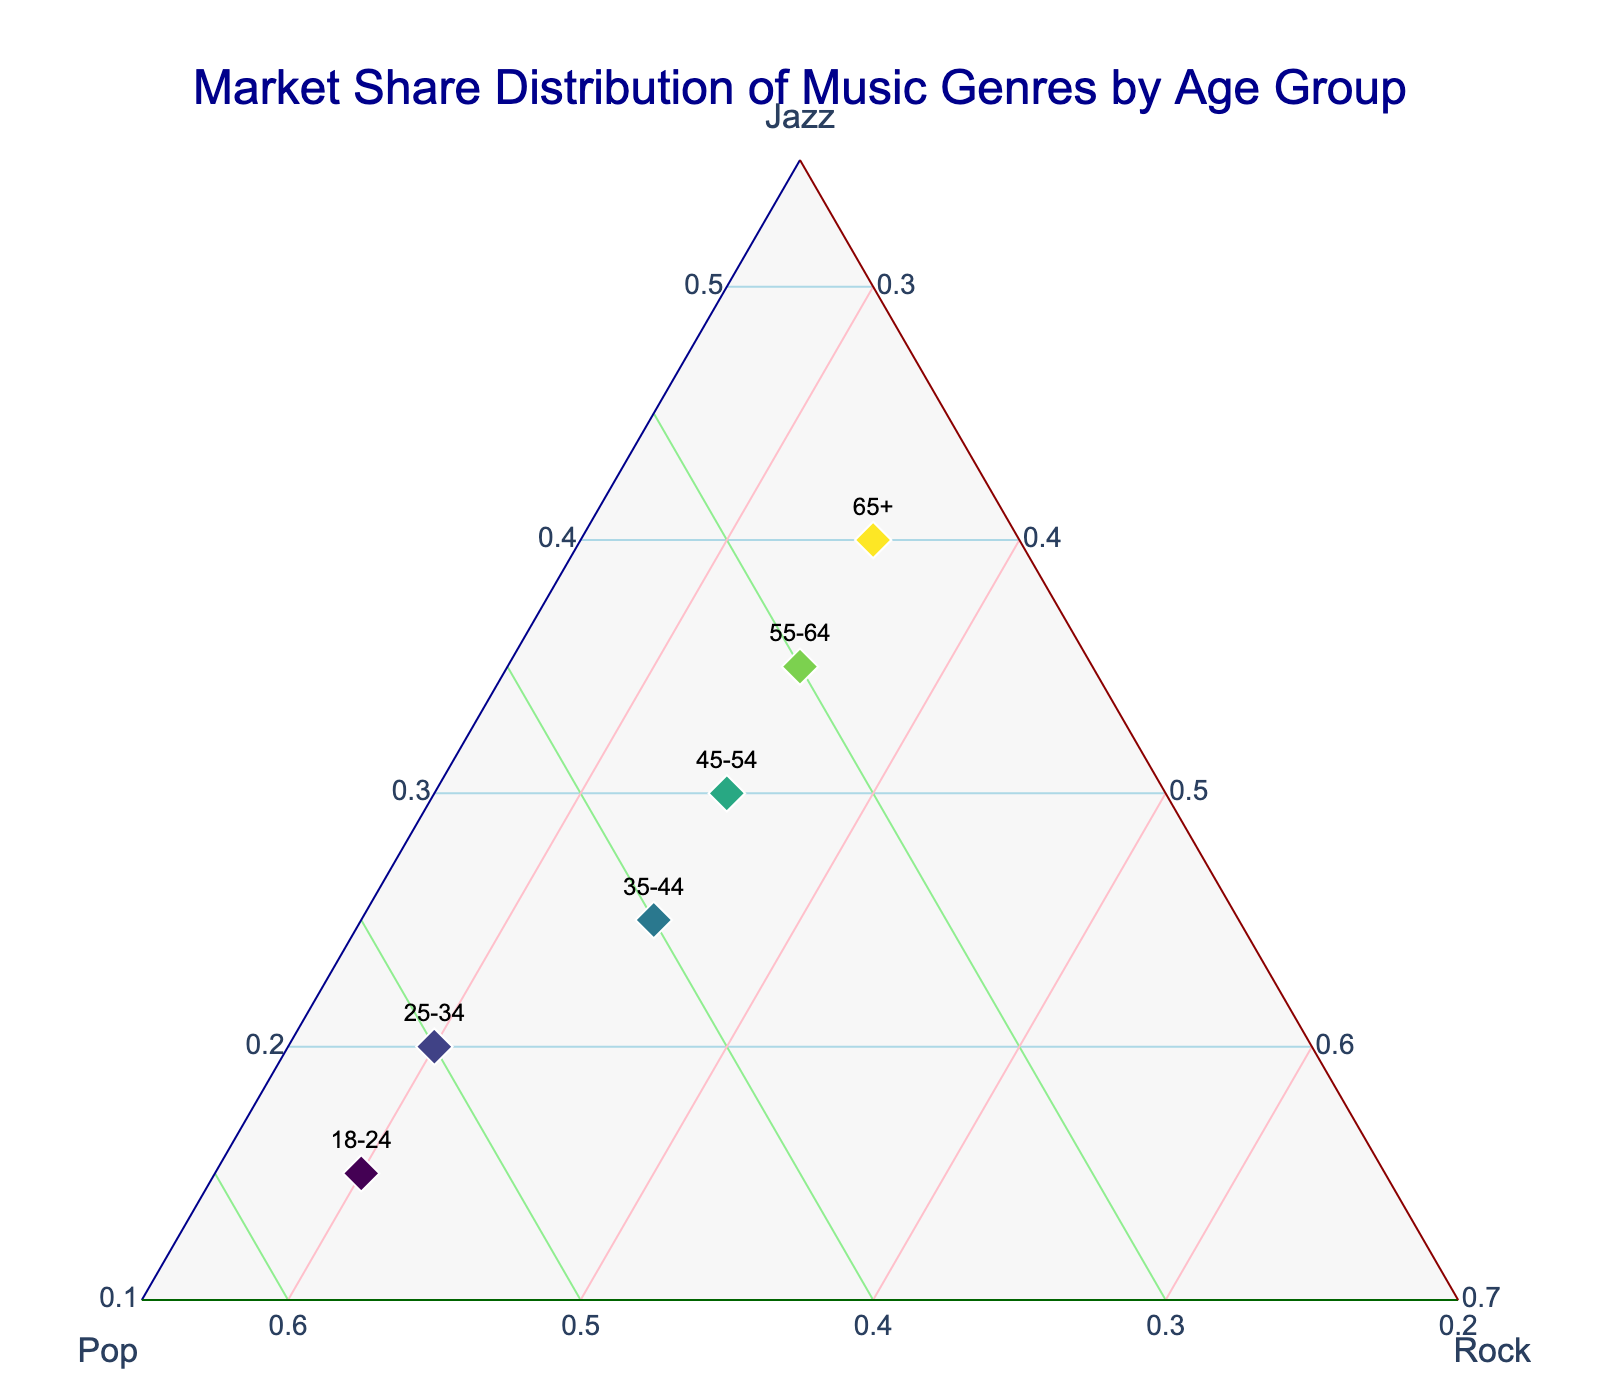What's the title of the ternary plot? The title is a text element usually found at the top of a plot. In this case, it describes the main theme of the data visualized.
Answer: Market Share Distribution of Music Genres by Age Group How many age groups are represented in the plot? Each marker or text on the plot represents a different age group. By counting these, we can determine the number of age groups.
Answer: Six Which age group has the highest preference for Jazz? By examining the axis titled "Jazz" and locating the point that is closest to 1 (or highest value), we can find the age group with the highest preference for Jazz.
Answer: 65+ Which age group prefers Pop the most? Look at the axis labeled "Pop" and find the point closest to the highest value on this axis.
Answer: 18-24 How does the preference for Jazz change with age? Observe the markers along the Jazz axis for each age group, noting whether the values increase or decrease as the age groups progress.
Answer: Preference for Jazz increases with age Which two age groups have the same preference for Rock? Identify points on the Rock axis and check for those that share the same value.
Answer: 35-44, 45-54, 55-64, 65+ By how much does the preference for Pop decrease from age group 18-24 to 25-34? Check the Pop values for both age groups and compute the difference between them.
Answer: 0.05 Which three age groups have at least 35% preference for Rock? Look at the labels and find points where the Rock values are 0.35 or higher.
Answer: 35-44, 45-54, 55-64, 65+ Which two age groups have almost equal preferences for all three music genres? Locate points that are closest to the center of the plot, indicating similar amounts for Jazz, Pop, and Rock.
Answer: 45-54 and 55-64 Would you consider jazz a niche market based on the preferences across different age groups? Analyze the distribution of Jazz preferences across all age groups. Considering that Jazz preference increases steadily with age and even reaches 40% for the 65+ age group, it may not be as niche as presumed.
Answer: No 